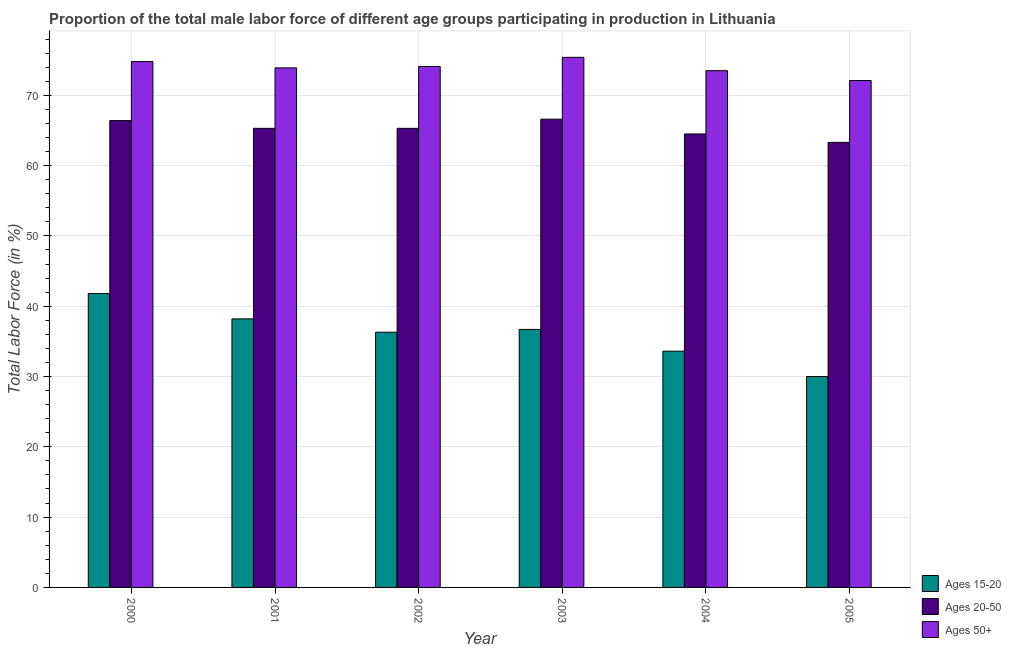How many groups of bars are there?
Provide a succinct answer. 6. What is the label of the 5th group of bars from the left?
Ensure brevity in your answer.  2004. What is the percentage of male labor force above age 50 in 2001?
Your answer should be very brief. 73.9. Across all years, what is the maximum percentage of male labor force within the age group 15-20?
Your response must be concise. 41.8. In which year was the percentage of male labor force above age 50 maximum?
Your response must be concise. 2003. In which year was the percentage of male labor force within the age group 15-20 minimum?
Offer a terse response. 2005. What is the total percentage of male labor force within the age group 20-50 in the graph?
Make the answer very short. 391.4. What is the difference between the percentage of male labor force within the age group 15-20 in 2001 and that in 2005?
Offer a terse response. 8.2. What is the difference between the percentage of male labor force within the age group 20-50 in 2003 and the percentage of male labor force within the age group 15-20 in 2001?
Your answer should be compact. 1.3. What is the average percentage of male labor force within the age group 15-20 per year?
Offer a very short reply. 36.1. In the year 2005, what is the difference between the percentage of male labor force within the age group 20-50 and percentage of male labor force within the age group 15-20?
Give a very brief answer. 0. In how many years, is the percentage of male labor force above age 50 greater than 16 %?
Offer a terse response. 6. What is the ratio of the percentage of male labor force within the age group 20-50 in 2001 to that in 2005?
Keep it short and to the point. 1.03. Is the percentage of male labor force above age 50 in 2001 less than that in 2003?
Make the answer very short. Yes. What is the difference between the highest and the second highest percentage of male labor force within the age group 20-50?
Keep it short and to the point. 0.2. What is the difference between the highest and the lowest percentage of male labor force above age 50?
Make the answer very short. 3.3. Is the sum of the percentage of male labor force within the age group 15-20 in 2002 and 2005 greater than the maximum percentage of male labor force above age 50 across all years?
Give a very brief answer. Yes. What does the 1st bar from the left in 2003 represents?
Keep it short and to the point. Ages 15-20. What does the 3rd bar from the right in 2001 represents?
Your response must be concise. Ages 15-20. Is it the case that in every year, the sum of the percentage of male labor force within the age group 15-20 and percentage of male labor force within the age group 20-50 is greater than the percentage of male labor force above age 50?
Offer a terse response. Yes. Where does the legend appear in the graph?
Ensure brevity in your answer.  Bottom right. What is the title of the graph?
Provide a succinct answer. Proportion of the total male labor force of different age groups participating in production in Lithuania. What is the Total Labor Force (in %) of Ages 15-20 in 2000?
Your response must be concise. 41.8. What is the Total Labor Force (in %) of Ages 20-50 in 2000?
Your response must be concise. 66.4. What is the Total Labor Force (in %) of Ages 50+ in 2000?
Your response must be concise. 74.8. What is the Total Labor Force (in %) of Ages 15-20 in 2001?
Provide a short and direct response. 38.2. What is the Total Labor Force (in %) of Ages 20-50 in 2001?
Provide a short and direct response. 65.3. What is the Total Labor Force (in %) in Ages 50+ in 2001?
Ensure brevity in your answer.  73.9. What is the Total Labor Force (in %) in Ages 15-20 in 2002?
Provide a short and direct response. 36.3. What is the Total Labor Force (in %) of Ages 20-50 in 2002?
Ensure brevity in your answer.  65.3. What is the Total Labor Force (in %) of Ages 50+ in 2002?
Ensure brevity in your answer.  74.1. What is the Total Labor Force (in %) of Ages 15-20 in 2003?
Ensure brevity in your answer.  36.7. What is the Total Labor Force (in %) of Ages 20-50 in 2003?
Make the answer very short. 66.6. What is the Total Labor Force (in %) of Ages 50+ in 2003?
Your answer should be compact. 75.4. What is the Total Labor Force (in %) in Ages 15-20 in 2004?
Ensure brevity in your answer.  33.6. What is the Total Labor Force (in %) in Ages 20-50 in 2004?
Keep it short and to the point. 64.5. What is the Total Labor Force (in %) in Ages 50+ in 2004?
Give a very brief answer. 73.5. What is the Total Labor Force (in %) of Ages 20-50 in 2005?
Give a very brief answer. 63.3. What is the Total Labor Force (in %) of Ages 50+ in 2005?
Give a very brief answer. 72.1. Across all years, what is the maximum Total Labor Force (in %) in Ages 15-20?
Keep it short and to the point. 41.8. Across all years, what is the maximum Total Labor Force (in %) of Ages 20-50?
Your answer should be very brief. 66.6. Across all years, what is the maximum Total Labor Force (in %) in Ages 50+?
Provide a short and direct response. 75.4. Across all years, what is the minimum Total Labor Force (in %) in Ages 20-50?
Ensure brevity in your answer.  63.3. Across all years, what is the minimum Total Labor Force (in %) of Ages 50+?
Give a very brief answer. 72.1. What is the total Total Labor Force (in %) in Ages 15-20 in the graph?
Offer a terse response. 216.6. What is the total Total Labor Force (in %) of Ages 20-50 in the graph?
Ensure brevity in your answer.  391.4. What is the total Total Labor Force (in %) of Ages 50+ in the graph?
Offer a terse response. 443.8. What is the difference between the Total Labor Force (in %) in Ages 15-20 in 2000 and that in 2001?
Keep it short and to the point. 3.6. What is the difference between the Total Labor Force (in %) in Ages 20-50 in 2000 and that in 2001?
Keep it short and to the point. 1.1. What is the difference between the Total Labor Force (in %) in Ages 50+ in 2000 and that in 2001?
Provide a succinct answer. 0.9. What is the difference between the Total Labor Force (in %) in Ages 20-50 in 2000 and that in 2002?
Give a very brief answer. 1.1. What is the difference between the Total Labor Force (in %) in Ages 15-20 in 2000 and that in 2003?
Your answer should be compact. 5.1. What is the difference between the Total Labor Force (in %) in Ages 20-50 in 2000 and that in 2003?
Your answer should be very brief. -0.2. What is the difference between the Total Labor Force (in %) of Ages 50+ in 2000 and that in 2003?
Offer a terse response. -0.6. What is the difference between the Total Labor Force (in %) in Ages 15-20 in 2000 and that in 2004?
Make the answer very short. 8.2. What is the difference between the Total Labor Force (in %) of Ages 50+ in 2000 and that in 2005?
Your answer should be compact. 2.7. What is the difference between the Total Labor Force (in %) of Ages 20-50 in 2001 and that in 2002?
Keep it short and to the point. 0. What is the difference between the Total Labor Force (in %) in Ages 50+ in 2001 and that in 2002?
Provide a succinct answer. -0.2. What is the difference between the Total Labor Force (in %) in Ages 50+ in 2001 and that in 2003?
Offer a very short reply. -1.5. What is the difference between the Total Labor Force (in %) in Ages 15-20 in 2001 and that in 2004?
Offer a very short reply. 4.6. What is the difference between the Total Labor Force (in %) in Ages 50+ in 2001 and that in 2005?
Make the answer very short. 1.8. What is the difference between the Total Labor Force (in %) in Ages 15-20 in 2002 and that in 2004?
Keep it short and to the point. 2.7. What is the difference between the Total Labor Force (in %) in Ages 20-50 in 2002 and that in 2004?
Provide a succinct answer. 0.8. What is the difference between the Total Labor Force (in %) in Ages 50+ in 2002 and that in 2004?
Your answer should be very brief. 0.6. What is the difference between the Total Labor Force (in %) in Ages 50+ in 2002 and that in 2005?
Offer a very short reply. 2. What is the difference between the Total Labor Force (in %) in Ages 15-20 in 2003 and that in 2004?
Offer a very short reply. 3.1. What is the difference between the Total Labor Force (in %) of Ages 50+ in 2003 and that in 2004?
Provide a succinct answer. 1.9. What is the difference between the Total Labor Force (in %) in Ages 15-20 in 2003 and that in 2005?
Offer a terse response. 6.7. What is the difference between the Total Labor Force (in %) in Ages 50+ in 2003 and that in 2005?
Give a very brief answer. 3.3. What is the difference between the Total Labor Force (in %) in Ages 15-20 in 2004 and that in 2005?
Your response must be concise. 3.6. What is the difference between the Total Labor Force (in %) in Ages 50+ in 2004 and that in 2005?
Your answer should be compact. 1.4. What is the difference between the Total Labor Force (in %) in Ages 15-20 in 2000 and the Total Labor Force (in %) in Ages 20-50 in 2001?
Offer a terse response. -23.5. What is the difference between the Total Labor Force (in %) of Ages 15-20 in 2000 and the Total Labor Force (in %) of Ages 50+ in 2001?
Give a very brief answer. -32.1. What is the difference between the Total Labor Force (in %) in Ages 15-20 in 2000 and the Total Labor Force (in %) in Ages 20-50 in 2002?
Make the answer very short. -23.5. What is the difference between the Total Labor Force (in %) of Ages 15-20 in 2000 and the Total Labor Force (in %) of Ages 50+ in 2002?
Your response must be concise. -32.3. What is the difference between the Total Labor Force (in %) of Ages 20-50 in 2000 and the Total Labor Force (in %) of Ages 50+ in 2002?
Offer a very short reply. -7.7. What is the difference between the Total Labor Force (in %) of Ages 15-20 in 2000 and the Total Labor Force (in %) of Ages 20-50 in 2003?
Offer a very short reply. -24.8. What is the difference between the Total Labor Force (in %) of Ages 15-20 in 2000 and the Total Labor Force (in %) of Ages 50+ in 2003?
Give a very brief answer. -33.6. What is the difference between the Total Labor Force (in %) of Ages 20-50 in 2000 and the Total Labor Force (in %) of Ages 50+ in 2003?
Your response must be concise. -9. What is the difference between the Total Labor Force (in %) of Ages 15-20 in 2000 and the Total Labor Force (in %) of Ages 20-50 in 2004?
Give a very brief answer. -22.7. What is the difference between the Total Labor Force (in %) in Ages 15-20 in 2000 and the Total Labor Force (in %) in Ages 50+ in 2004?
Your response must be concise. -31.7. What is the difference between the Total Labor Force (in %) in Ages 15-20 in 2000 and the Total Labor Force (in %) in Ages 20-50 in 2005?
Your answer should be very brief. -21.5. What is the difference between the Total Labor Force (in %) of Ages 15-20 in 2000 and the Total Labor Force (in %) of Ages 50+ in 2005?
Make the answer very short. -30.3. What is the difference between the Total Labor Force (in %) in Ages 20-50 in 2000 and the Total Labor Force (in %) in Ages 50+ in 2005?
Keep it short and to the point. -5.7. What is the difference between the Total Labor Force (in %) in Ages 15-20 in 2001 and the Total Labor Force (in %) in Ages 20-50 in 2002?
Provide a short and direct response. -27.1. What is the difference between the Total Labor Force (in %) in Ages 15-20 in 2001 and the Total Labor Force (in %) in Ages 50+ in 2002?
Keep it short and to the point. -35.9. What is the difference between the Total Labor Force (in %) in Ages 15-20 in 2001 and the Total Labor Force (in %) in Ages 20-50 in 2003?
Your answer should be very brief. -28.4. What is the difference between the Total Labor Force (in %) in Ages 15-20 in 2001 and the Total Labor Force (in %) in Ages 50+ in 2003?
Your response must be concise. -37.2. What is the difference between the Total Labor Force (in %) in Ages 20-50 in 2001 and the Total Labor Force (in %) in Ages 50+ in 2003?
Ensure brevity in your answer.  -10.1. What is the difference between the Total Labor Force (in %) of Ages 15-20 in 2001 and the Total Labor Force (in %) of Ages 20-50 in 2004?
Your answer should be compact. -26.3. What is the difference between the Total Labor Force (in %) in Ages 15-20 in 2001 and the Total Labor Force (in %) in Ages 50+ in 2004?
Give a very brief answer. -35.3. What is the difference between the Total Labor Force (in %) of Ages 20-50 in 2001 and the Total Labor Force (in %) of Ages 50+ in 2004?
Keep it short and to the point. -8.2. What is the difference between the Total Labor Force (in %) of Ages 15-20 in 2001 and the Total Labor Force (in %) of Ages 20-50 in 2005?
Provide a succinct answer. -25.1. What is the difference between the Total Labor Force (in %) of Ages 15-20 in 2001 and the Total Labor Force (in %) of Ages 50+ in 2005?
Provide a succinct answer. -33.9. What is the difference between the Total Labor Force (in %) of Ages 15-20 in 2002 and the Total Labor Force (in %) of Ages 20-50 in 2003?
Ensure brevity in your answer.  -30.3. What is the difference between the Total Labor Force (in %) of Ages 15-20 in 2002 and the Total Labor Force (in %) of Ages 50+ in 2003?
Provide a succinct answer. -39.1. What is the difference between the Total Labor Force (in %) of Ages 20-50 in 2002 and the Total Labor Force (in %) of Ages 50+ in 2003?
Your response must be concise. -10.1. What is the difference between the Total Labor Force (in %) of Ages 15-20 in 2002 and the Total Labor Force (in %) of Ages 20-50 in 2004?
Ensure brevity in your answer.  -28.2. What is the difference between the Total Labor Force (in %) in Ages 15-20 in 2002 and the Total Labor Force (in %) in Ages 50+ in 2004?
Make the answer very short. -37.2. What is the difference between the Total Labor Force (in %) of Ages 15-20 in 2002 and the Total Labor Force (in %) of Ages 50+ in 2005?
Make the answer very short. -35.8. What is the difference between the Total Labor Force (in %) of Ages 15-20 in 2003 and the Total Labor Force (in %) of Ages 20-50 in 2004?
Your answer should be compact. -27.8. What is the difference between the Total Labor Force (in %) of Ages 15-20 in 2003 and the Total Labor Force (in %) of Ages 50+ in 2004?
Give a very brief answer. -36.8. What is the difference between the Total Labor Force (in %) of Ages 20-50 in 2003 and the Total Labor Force (in %) of Ages 50+ in 2004?
Your answer should be very brief. -6.9. What is the difference between the Total Labor Force (in %) of Ages 15-20 in 2003 and the Total Labor Force (in %) of Ages 20-50 in 2005?
Provide a succinct answer. -26.6. What is the difference between the Total Labor Force (in %) of Ages 15-20 in 2003 and the Total Labor Force (in %) of Ages 50+ in 2005?
Offer a very short reply. -35.4. What is the difference between the Total Labor Force (in %) in Ages 15-20 in 2004 and the Total Labor Force (in %) in Ages 20-50 in 2005?
Give a very brief answer. -29.7. What is the difference between the Total Labor Force (in %) in Ages 15-20 in 2004 and the Total Labor Force (in %) in Ages 50+ in 2005?
Your answer should be very brief. -38.5. What is the average Total Labor Force (in %) in Ages 15-20 per year?
Offer a very short reply. 36.1. What is the average Total Labor Force (in %) of Ages 20-50 per year?
Ensure brevity in your answer.  65.23. What is the average Total Labor Force (in %) in Ages 50+ per year?
Your answer should be compact. 73.97. In the year 2000, what is the difference between the Total Labor Force (in %) of Ages 15-20 and Total Labor Force (in %) of Ages 20-50?
Give a very brief answer. -24.6. In the year 2000, what is the difference between the Total Labor Force (in %) of Ages 15-20 and Total Labor Force (in %) of Ages 50+?
Ensure brevity in your answer.  -33. In the year 2001, what is the difference between the Total Labor Force (in %) in Ages 15-20 and Total Labor Force (in %) in Ages 20-50?
Ensure brevity in your answer.  -27.1. In the year 2001, what is the difference between the Total Labor Force (in %) in Ages 15-20 and Total Labor Force (in %) in Ages 50+?
Offer a terse response. -35.7. In the year 2001, what is the difference between the Total Labor Force (in %) of Ages 20-50 and Total Labor Force (in %) of Ages 50+?
Provide a succinct answer. -8.6. In the year 2002, what is the difference between the Total Labor Force (in %) of Ages 15-20 and Total Labor Force (in %) of Ages 20-50?
Your response must be concise. -29. In the year 2002, what is the difference between the Total Labor Force (in %) of Ages 15-20 and Total Labor Force (in %) of Ages 50+?
Offer a very short reply. -37.8. In the year 2002, what is the difference between the Total Labor Force (in %) of Ages 20-50 and Total Labor Force (in %) of Ages 50+?
Make the answer very short. -8.8. In the year 2003, what is the difference between the Total Labor Force (in %) in Ages 15-20 and Total Labor Force (in %) in Ages 20-50?
Ensure brevity in your answer.  -29.9. In the year 2003, what is the difference between the Total Labor Force (in %) in Ages 15-20 and Total Labor Force (in %) in Ages 50+?
Ensure brevity in your answer.  -38.7. In the year 2004, what is the difference between the Total Labor Force (in %) in Ages 15-20 and Total Labor Force (in %) in Ages 20-50?
Make the answer very short. -30.9. In the year 2004, what is the difference between the Total Labor Force (in %) in Ages 15-20 and Total Labor Force (in %) in Ages 50+?
Offer a terse response. -39.9. In the year 2005, what is the difference between the Total Labor Force (in %) of Ages 15-20 and Total Labor Force (in %) of Ages 20-50?
Offer a very short reply. -33.3. In the year 2005, what is the difference between the Total Labor Force (in %) in Ages 15-20 and Total Labor Force (in %) in Ages 50+?
Make the answer very short. -42.1. In the year 2005, what is the difference between the Total Labor Force (in %) in Ages 20-50 and Total Labor Force (in %) in Ages 50+?
Your response must be concise. -8.8. What is the ratio of the Total Labor Force (in %) of Ages 15-20 in 2000 to that in 2001?
Make the answer very short. 1.09. What is the ratio of the Total Labor Force (in %) in Ages 20-50 in 2000 to that in 2001?
Your answer should be very brief. 1.02. What is the ratio of the Total Labor Force (in %) of Ages 50+ in 2000 to that in 2001?
Give a very brief answer. 1.01. What is the ratio of the Total Labor Force (in %) of Ages 15-20 in 2000 to that in 2002?
Your answer should be compact. 1.15. What is the ratio of the Total Labor Force (in %) of Ages 20-50 in 2000 to that in 2002?
Offer a terse response. 1.02. What is the ratio of the Total Labor Force (in %) in Ages 50+ in 2000 to that in 2002?
Your answer should be very brief. 1.01. What is the ratio of the Total Labor Force (in %) of Ages 15-20 in 2000 to that in 2003?
Offer a very short reply. 1.14. What is the ratio of the Total Labor Force (in %) of Ages 50+ in 2000 to that in 2003?
Provide a succinct answer. 0.99. What is the ratio of the Total Labor Force (in %) of Ages 15-20 in 2000 to that in 2004?
Ensure brevity in your answer.  1.24. What is the ratio of the Total Labor Force (in %) in Ages 20-50 in 2000 to that in 2004?
Offer a terse response. 1.03. What is the ratio of the Total Labor Force (in %) of Ages 50+ in 2000 to that in 2004?
Provide a short and direct response. 1.02. What is the ratio of the Total Labor Force (in %) in Ages 15-20 in 2000 to that in 2005?
Provide a short and direct response. 1.39. What is the ratio of the Total Labor Force (in %) of Ages 20-50 in 2000 to that in 2005?
Make the answer very short. 1.05. What is the ratio of the Total Labor Force (in %) in Ages 50+ in 2000 to that in 2005?
Your response must be concise. 1.04. What is the ratio of the Total Labor Force (in %) in Ages 15-20 in 2001 to that in 2002?
Keep it short and to the point. 1.05. What is the ratio of the Total Labor Force (in %) in Ages 20-50 in 2001 to that in 2002?
Make the answer very short. 1. What is the ratio of the Total Labor Force (in %) of Ages 50+ in 2001 to that in 2002?
Provide a short and direct response. 1. What is the ratio of the Total Labor Force (in %) of Ages 15-20 in 2001 to that in 2003?
Your answer should be compact. 1.04. What is the ratio of the Total Labor Force (in %) in Ages 20-50 in 2001 to that in 2003?
Your answer should be compact. 0.98. What is the ratio of the Total Labor Force (in %) of Ages 50+ in 2001 to that in 2003?
Ensure brevity in your answer.  0.98. What is the ratio of the Total Labor Force (in %) of Ages 15-20 in 2001 to that in 2004?
Keep it short and to the point. 1.14. What is the ratio of the Total Labor Force (in %) of Ages 20-50 in 2001 to that in 2004?
Offer a terse response. 1.01. What is the ratio of the Total Labor Force (in %) in Ages 50+ in 2001 to that in 2004?
Provide a succinct answer. 1.01. What is the ratio of the Total Labor Force (in %) of Ages 15-20 in 2001 to that in 2005?
Offer a very short reply. 1.27. What is the ratio of the Total Labor Force (in %) in Ages 20-50 in 2001 to that in 2005?
Your answer should be very brief. 1.03. What is the ratio of the Total Labor Force (in %) of Ages 20-50 in 2002 to that in 2003?
Your answer should be very brief. 0.98. What is the ratio of the Total Labor Force (in %) of Ages 50+ in 2002 to that in 2003?
Make the answer very short. 0.98. What is the ratio of the Total Labor Force (in %) of Ages 15-20 in 2002 to that in 2004?
Provide a succinct answer. 1.08. What is the ratio of the Total Labor Force (in %) of Ages 20-50 in 2002 to that in 2004?
Provide a succinct answer. 1.01. What is the ratio of the Total Labor Force (in %) of Ages 50+ in 2002 to that in 2004?
Your answer should be compact. 1.01. What is the ratio of the Total Labor Force (in %) of Ages 15-20 in 2002 to that in 2005?
Ensure brevity in your answer.  1.21. What is the ratio of the Total Labor Force (in %) in Ages 20-50 in 2002 to that in 2005?
Your answer should be compact. 1.03. What is the ratio of the Total Labor Force (in %) in Ages 50+ in 2002 to that in 2005?
Keep it short and to the point. 1.03. What is the ratio of the Total Labor Force (in %) of Ages 15-20 in 2003 to that in 2004?
Offer a very short reply. 1.09. What is the ratio of the Total Labor Force (in %) in Ages 20-50 in 2003 to that in 2004?
Offer a terse response. 1.03. What is the ratio of the Total Labor Force (in %) in Ages 50+ in 2003 to that in 2004?
Offer a terse response. 1.03. What is the ratio of the Total Labor Force (in %) of Ages 15-20 in 2003 to that in 2005?
Your response must be concise. 1.22. What is the ratio of the Total Labor Force (in %) in Ages 20-50 in 2003 to that in 2005?
Keep it short and to the point. 1.05. What is the ratio of the Total Labor Force (in %) of Ages 50+ in 2003 to that in 2005?
Keep it short and to the point. 1.05. What is the ratio of the Total Labor Force (in %) in Ages 15-20 in 2004 to that in 2005?
Ensure brevity in your answer.  1.12. What is the ratio of the Total Labor Force (in %) of Ages 50+ in 2004 to that in 2005?
Make the answer very short. 1.02. What is the difference between the highest and the second highest Total Labor Force (in %) in Ages 20-50?
Your answer should be compact. 0.2. What is the difference between the highest and the lowest Total Labor Force (in %) of Ages 15-20?
Give a very brief answer. 11.8. What is the difference between the highest and the lowest Total Labor Force (in %) of Ages 20-50?
Provide a succinct answer. 3.3. 